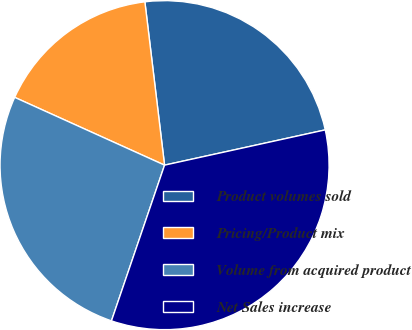<chart> <loc_0><loc_0><loc_500><loc_500><pie_chart><fcel>Product volumes sold<fcel>Pricing/Product mix<fcel>Volume from acquired product<fcel>Net Sales increase<nl><fcel>23.47%<fcel>16.33%<fcel>26.53%<fcel>33.67%<nl></chart> 